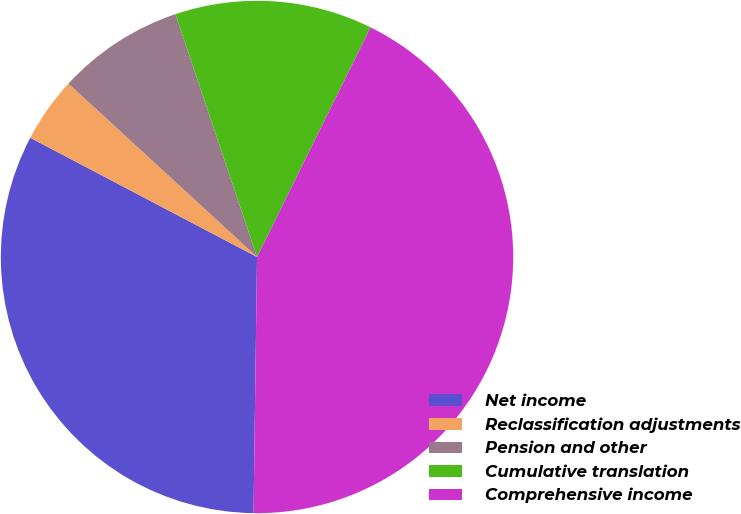<chart> <loc_0><loc_0><loc_500><loc_500><pie_chart><fcel>Net income<fcel>Reclassification adjustments<fcel>Pension and other<fcel>Cumulative translation<fcel>Comprehensive income<nl><fcel>32.49%<fcel>4.13%<fcel>8.01%<fcel>12.47%<fcel>42.91%<nl></chart> 